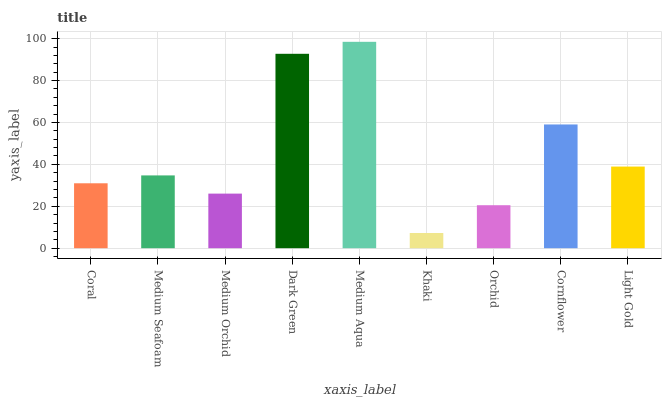Is Khaki the minimum?
Answer yes or no. Yes. Is Medium Aqua the maximum?
Answer yes or no. Yes. Is Medium Seafoam the minimum?
Answer yes or no. No. Is Medium Seafoam the maximum?
Answer yes or no. No. Is Medium Seafoam greater than Coral?
Answer yes or no. Yes. Is Coral less than Medium Seafoam?
Answer yes or no. Yes. Is Coral greater than Medium Seafoam?
Answer yes or no. No. Is Medium Seafoam less than Coral?
Answer yes or no. No. Is Medium Seafoam the high median?
Answer yes or no. Yes. Is Medium Seafoam the low median?
Answer yes or no. Yes. Is Medium Orchid the high median?
Answer yes or no. No. Is Coral the low median?
Answer yes or no. No. 